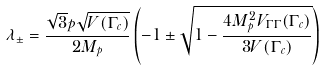Convert formula to latex. <formula><loc_0><loc_0><loc_500><loc_500>\lambda _ { \pm } = \frac { \sqrt { 3 } p \sqrt { V ( \Gamma _ { c } ) } } { 2 M _ { p } } \left ( - 1 \pm \sqrt { 1 - \frac { 4 M _ { p } ^ { 2 } V _ { \Gamma \Gamma } ( \Gamma _ { c } ) } { 3 V ( \Gamma _ { c } ) } } \right )</formula> 